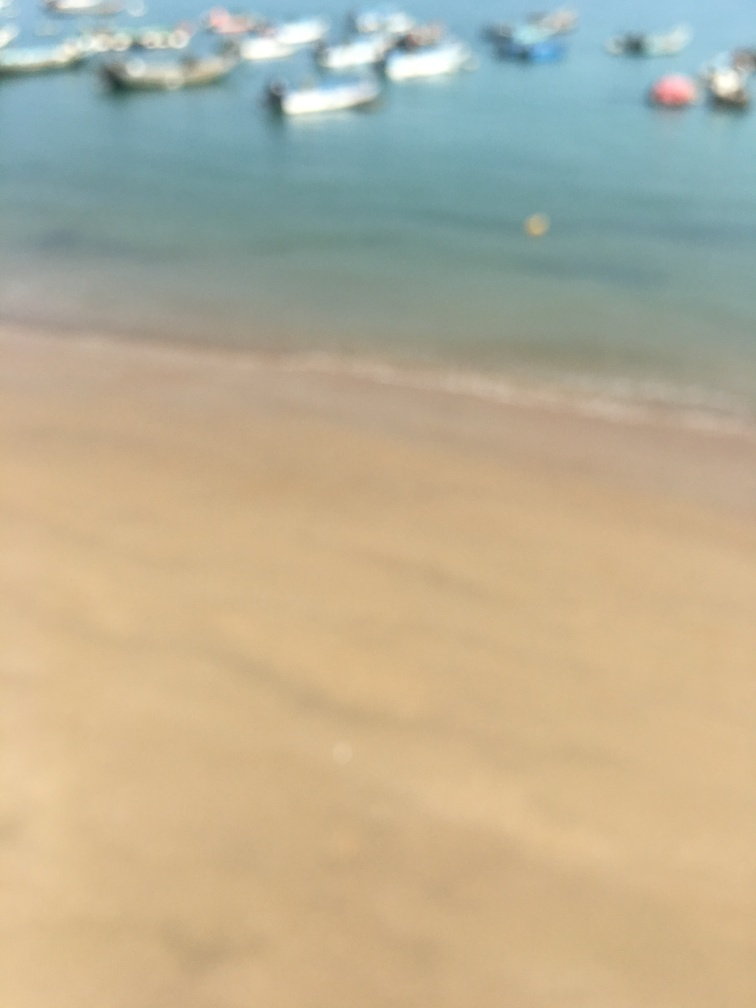Is the ground blurry? Indeed, the ground in the image is quite blurry, with a lack of sharp detail that obscures specific features of the beach and the sea’s edge. 